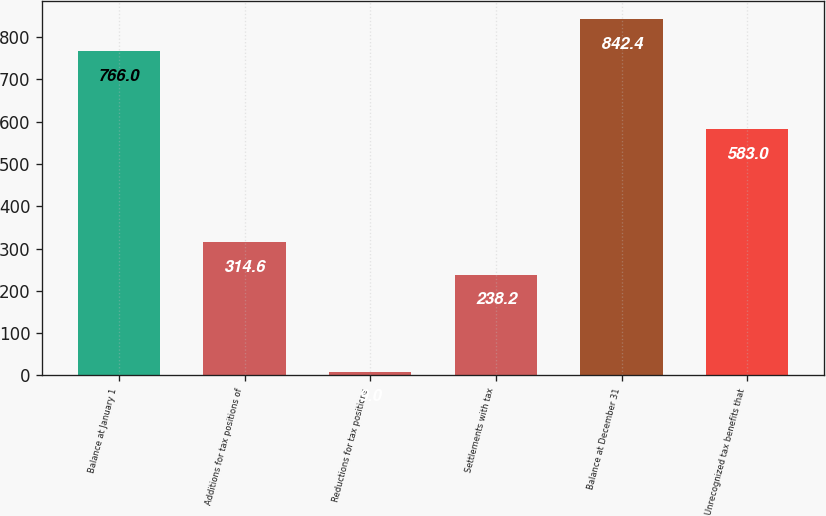Convert chart to OTSL. <chart><loc_0><loc_0><loc_500><loc_500><bar_chart><fcel>Balance at January 1<fcel>Additions for tax positions of<fcel>Reductions for tax positions<fcel>Settlements with tax<fcel>Balance at December 31<fcel>Unrecognized tax benefits that<nl><fcel>766<fcel>314.6<fcel>9<fcel>238.2<fcel>842.4<fcel>583<nl></chart> 